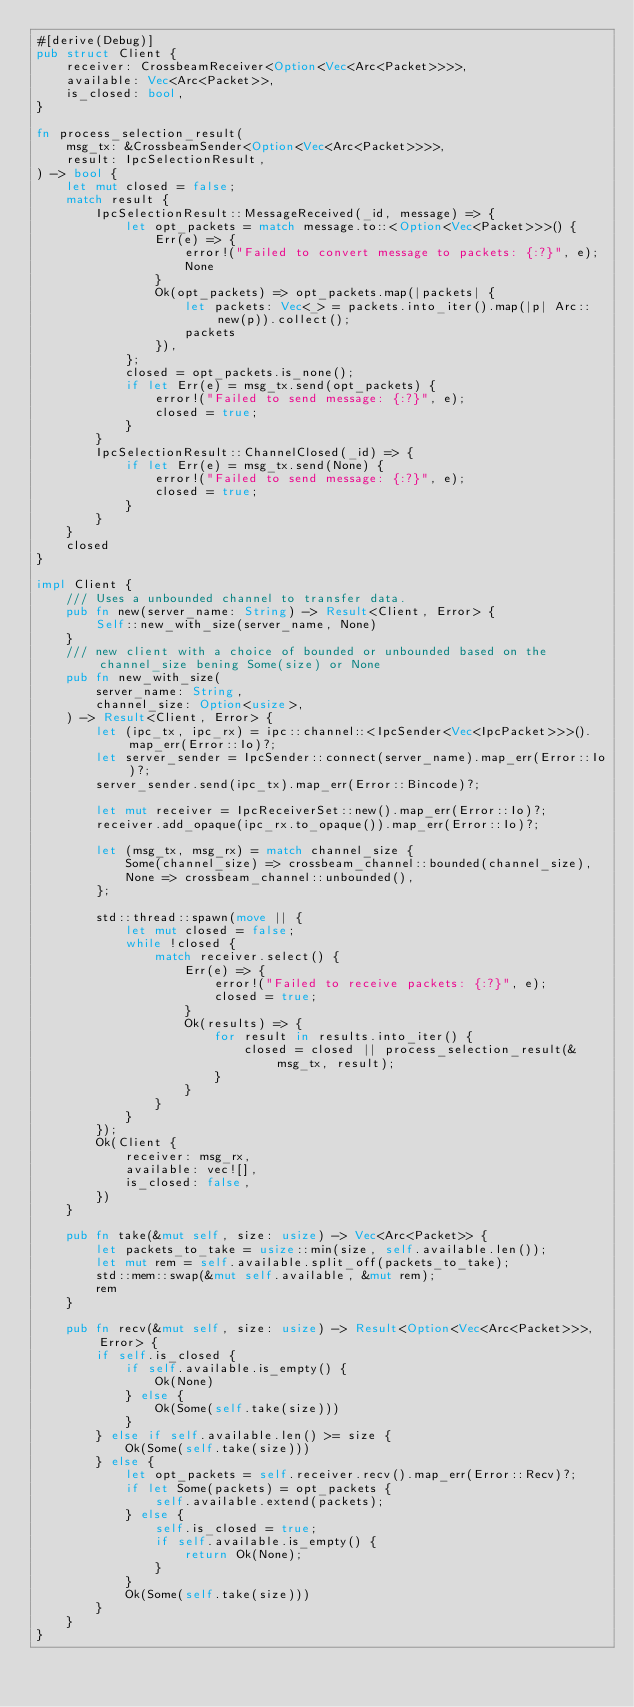Convert code to text. <code><loc_0><loc_0><loc_500><loc_500><_Rust_>#[derive(Debug)]
pub struct Client {
    receiver: CrossbeamReceiver<Option<Vec<Arc<Packet>>>>,
    available: Vec<Arc<Packet>>,
    is_closed: bool,
}

fn process_selection_result(
    msg_tx: &CrossbeamSender<Option<Vec<Arc<Packet>>>>,
    result: IpcSelectionResult,
) -> bool {
    let mut closed = false;
    match result {
        IpcSelectionResult::MessageReceived(_id, message) => {
            let opt_packets = match message.to::<Option<Vec<Packet>>>() {
                Err(e) => {
                    error!("Failed to convert message to packets: {:?}", e);
                    None
                }
                Ok(opt_packets) => opt_packets.map(|packets| {
                    let packets: Vec<_> = packets.into_iter().map(|p| Arc::new(p)).collect();
                    packets
                }),
            };
            closed = opt_packets.is_none();
            if let Err(e) = msg_tx.send(opt_packets) {
                error!("Failed to send message: {:?}", e);
                closed = true;
            }
        }
        IpcSelectionResult::ChannelClosed(_id) => {
            if let Err(e) = msg_tx.send(None) {
                error!("Failed to send message: {:?}", e);
                closed = true;
            }
        }
    }
    closed
}

impl Client {
    /// Uses a unbounded channel to transfer data.
    pub fn new(server_name: String) -> Result<Client, Error> {
        Self::new_with_size(server_name, None)
    }
    /// new client with a choice of bounded or unbounded based on the channel_size bening Some(size) or None
    pub fn new_with_size(
        server_name: String,
        channel_size: Option<usize>,
    ) -> Result<Client, Error> {
        let (ipc_tx, ipc_rx) = ipc::channel::<IpcSender<Vec<IpcPacket>>>().map_err(Error::Io)?;
        let server_sender = IpcSender::connect(server_name).map_err(Error::Io)?;
        server_sender.send(ipc_tx).map_err(Error::Bincode)?;

        let mut receiver = IpcReceiverSet::new().map_err(Error::Io)?;
        receiver.add_opaque(ipc_rx.to_opaque()).map_err(Error::Io)?;

        let (msg_tx, msg_rx) = match channel_size {
            Some(channel_size) => crossbeam_channel::bounded(channel_size),
            None => crossbeam_channel::unbounded(),
        };

        std::thread::spawn(move || {
            let mut closed = false;
            while !closed {
                match receiver.select() {
                    Err(e) => {
                        error!("Failed to receive packets: {:?}", e);
                        closed = true;
                    }
                    Ok(results) => {
                        for result in results.into_iter() {
                            closed = closed || process_selection_result(&msg_tx, result);
                        }
                    }
                }
            }
        });
        Ok(Client {
            receiver: msg_rx,
            available: vec![],
            is_closed: false,
        })
    }

    pub fn take(&mut self, size: usize) -> Vec<Arc<Packet>> {
        let packets_to_take = usize::min(size, self.available.len());
        let mut rem = self.available.split_off(packets_to_take);
        std::mem::swap(&mut self.available, &mut rem);
        rem
    }

    pub fn recv(&mut self, size: usize) -> Result<Option<Vec<Arc<Packet>>>, Error> {
        if self.is_closed {
            if self.available.is_empty() {
                Ok(None)
            } else {
                Ok(Some(self.take(size)))
            }
        } else if self.available.len() >= size {
            Ok(Some(self.take(size)))
        } else {
            let opt_packets = self.receiver.recv().map_err(Error::Recv)?;
            if let Some(packets) = opt_packets {
                self.available.extend(packets);
            } else {
                self.is_closed = true;
                if self.available.is_empty() {
                    return Ok(None);
                }
            }
            Ok(Some(self.take(size)))
        }
    }
}
</code> 